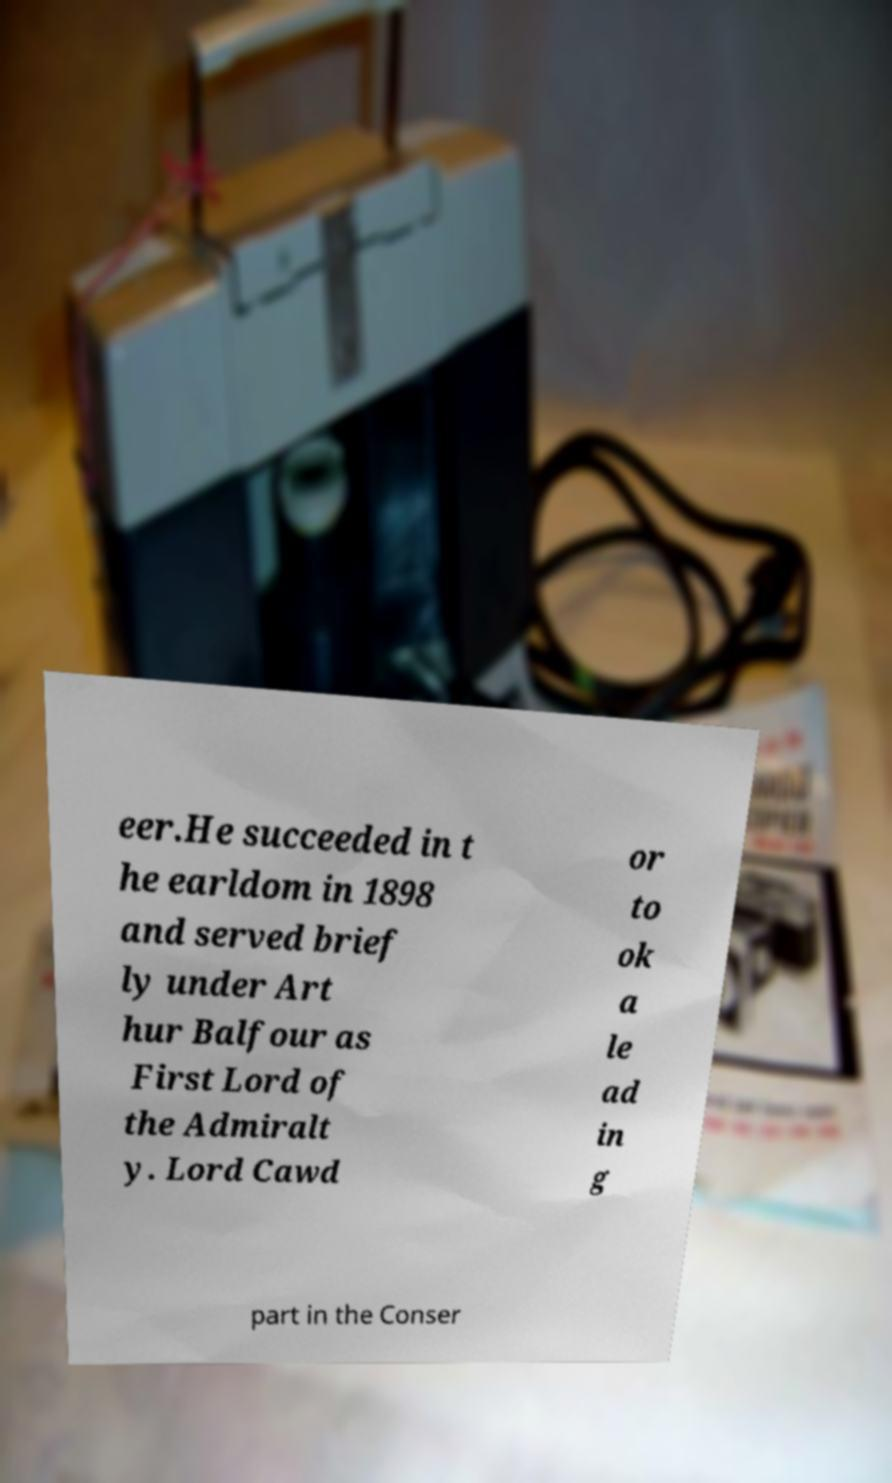Could you assist in decoding the text presented in this image and type it out clearly? eer.He succeeded in t he earldom in 1898 and served brief ly under Art hur Balfour as First Lord of the Admiralt y. Lord Cawd or to ok a le ad in g part in the Conser 